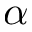<formula> <loc_0><loc_0><loc_500><loc_500>\alpha</formula> 